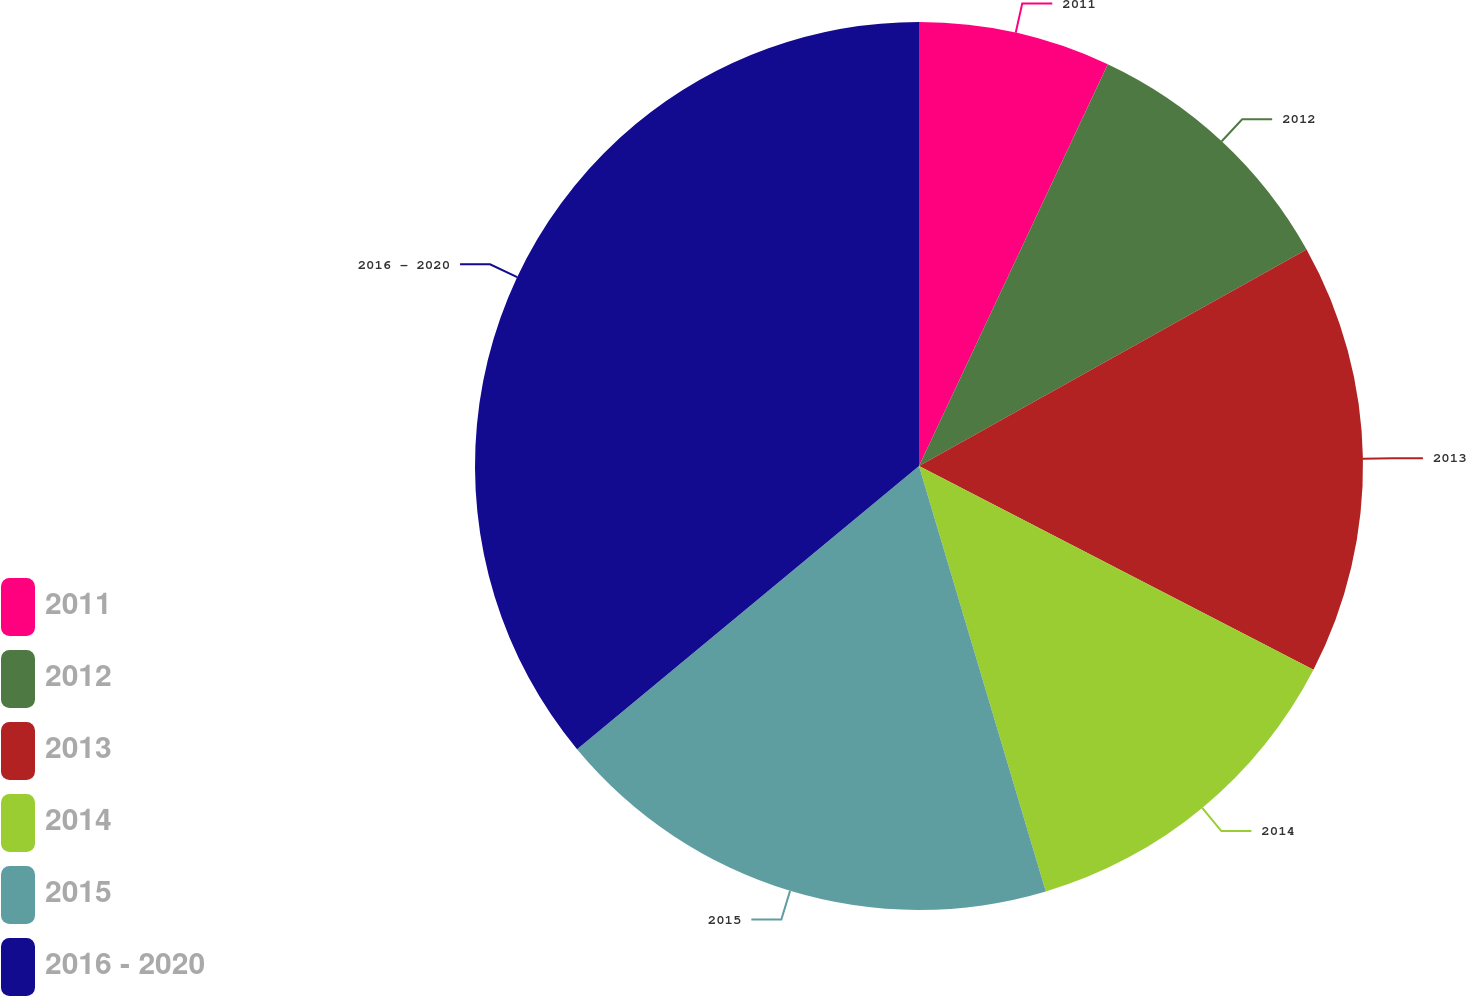<chart> <loc_0><loc_0><loc_500><loc_500><pie_chart><fcel>2011<fcel>2012<fcel>2013<fcel>2014<fcel>2015<fcel>2016 - 2020<nl><fcel>6.99%<fcel>9.9%<fcel>15.7%<fcel>12.8%<fcel>18.6%<fcel>36.01%<nl></chart> 